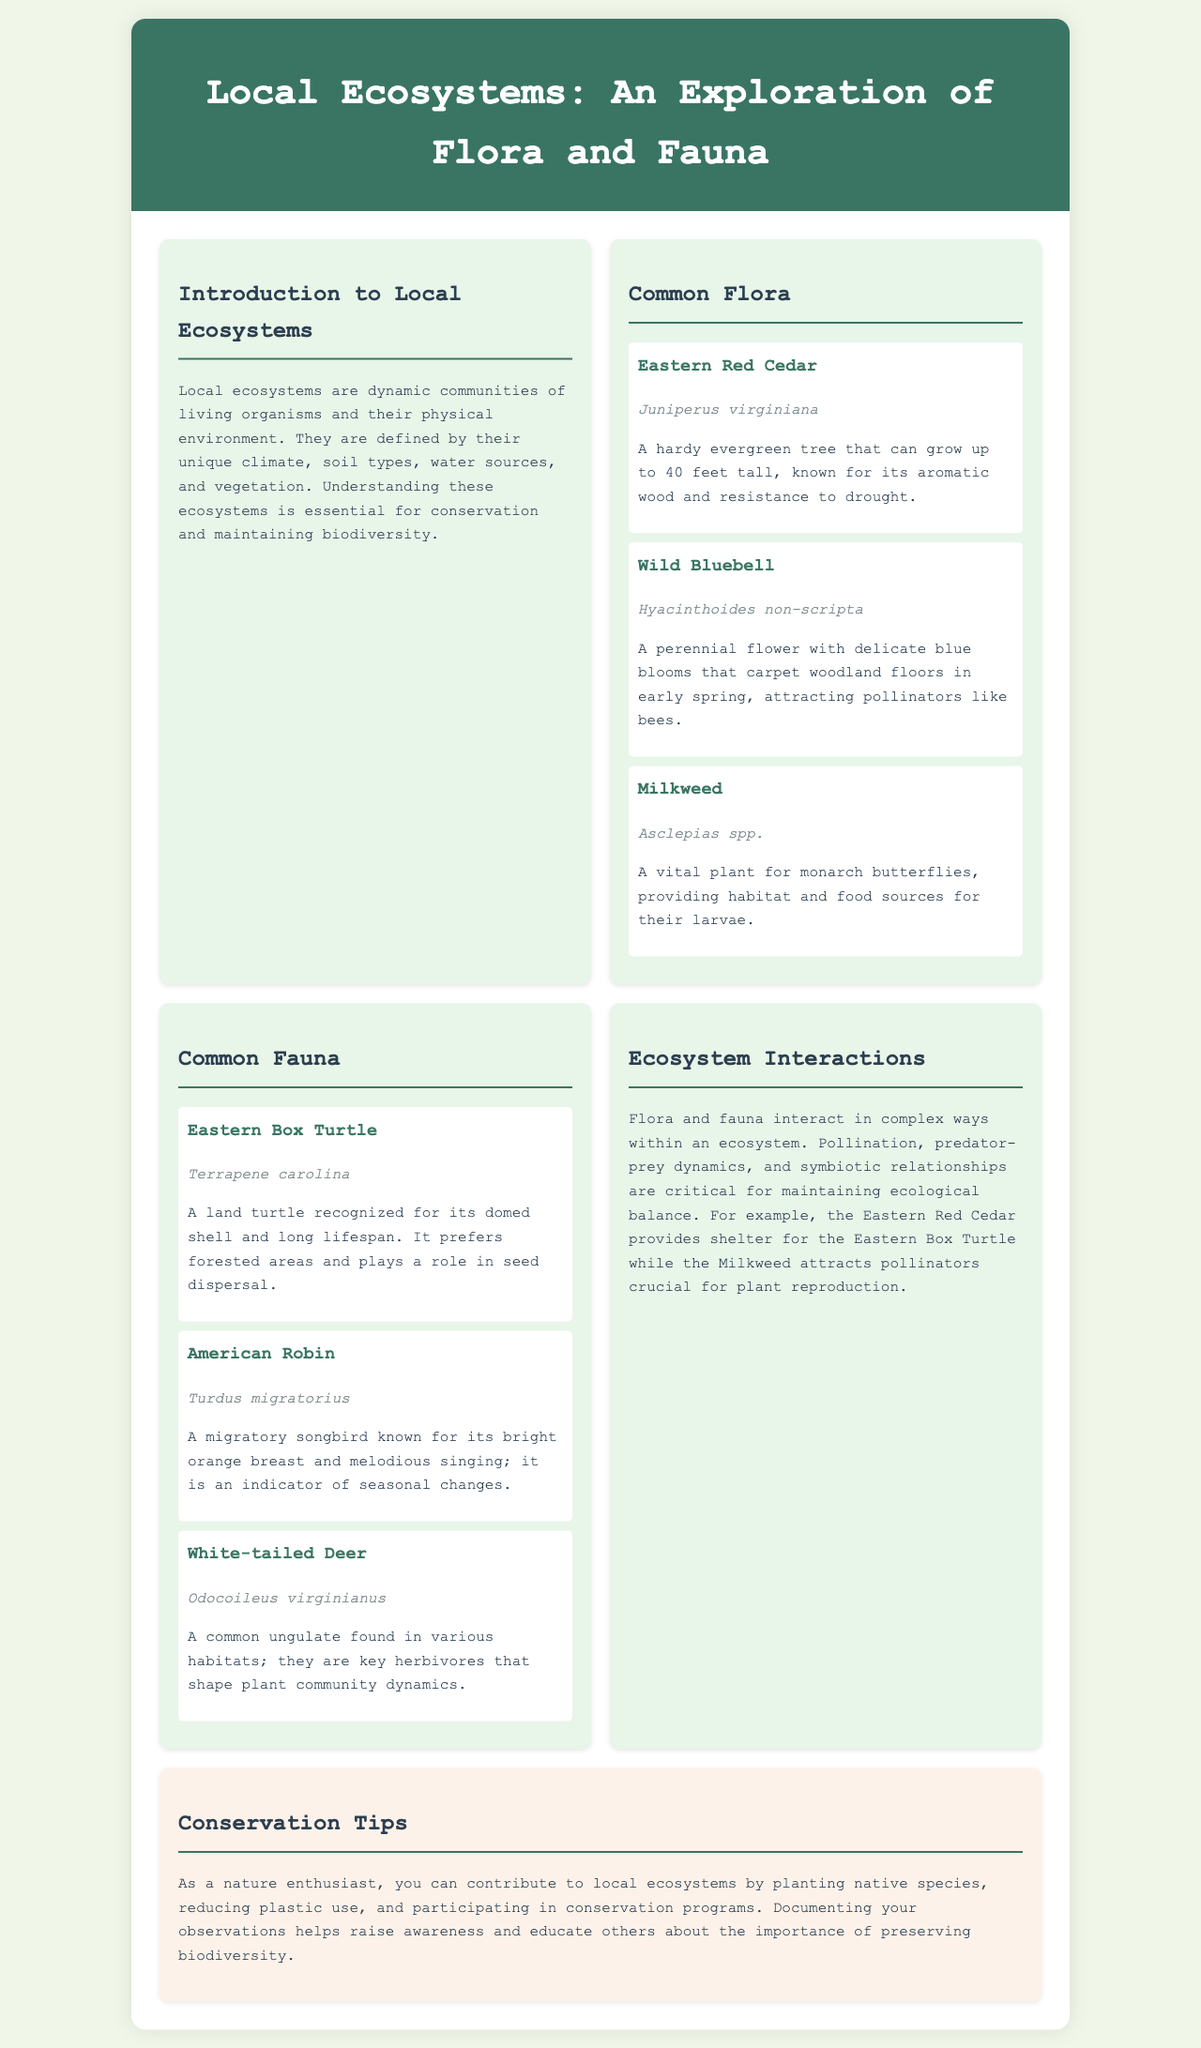What is the title of the brochure? The title is displayed prominently at the top of the document, indicating the main topic covered.
Answer: Local Ecosystems: An Exploration of Flora and Fauna How many common flora species are mentioned? The section lists three different flora species, providing names and descriptions for each.
Answer: 3 What is the scientific name of the Eastern Box Turtle? The scientific name is given in italics following the common name in the fauna section.
Answer: Terrapene carolina Which flower attracts pollinators like bees? The brochure specifies which plant is vital for pollinators in its description, emphasizing its ecological role.
Answer: Wild Bluebell What key herbivores shape plant community dynamics? The fauna section highlights the role of certain animals in local ecosystems, identifying specific examples.
Answer: White-tailed Deer What is one tip provided for conservation? This question seeks practical advice aimed at individuals who want to contribute positively to local ecosystems.
Answer: Planting native species How do flora and fauna interact in ecosystems? The document provides insights into the relationships and functions of different organisms within their habitats.
Answer: Pollination, predator-prey dynamics, and symbiotic relationships What is the maximum width of the brochure design? This identifies a design specification mentioned in the code, relevant for understanding the document layout.
Answer: 1000px 